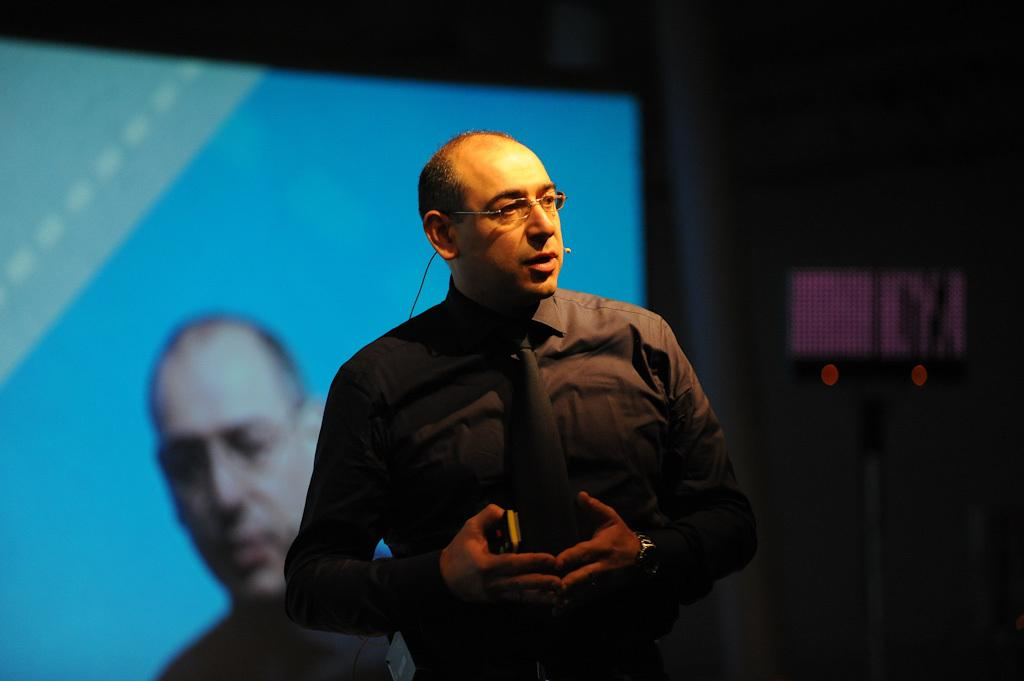What is the main subject of the image? There is a man standing in the center of the image. What is the man holding in his hand? The man is holding a mobile in his hand. What can be seen in the background of the image? There is a screen in the background of the image. Where is the light located in the image? There is a light on the right side of the image. What type of leather is covering the tray in the image? There is no tray or leather present in the image. How many ducks can be seen swimming in the background of the image? There are no ducks present in the image; the background features a screen. 